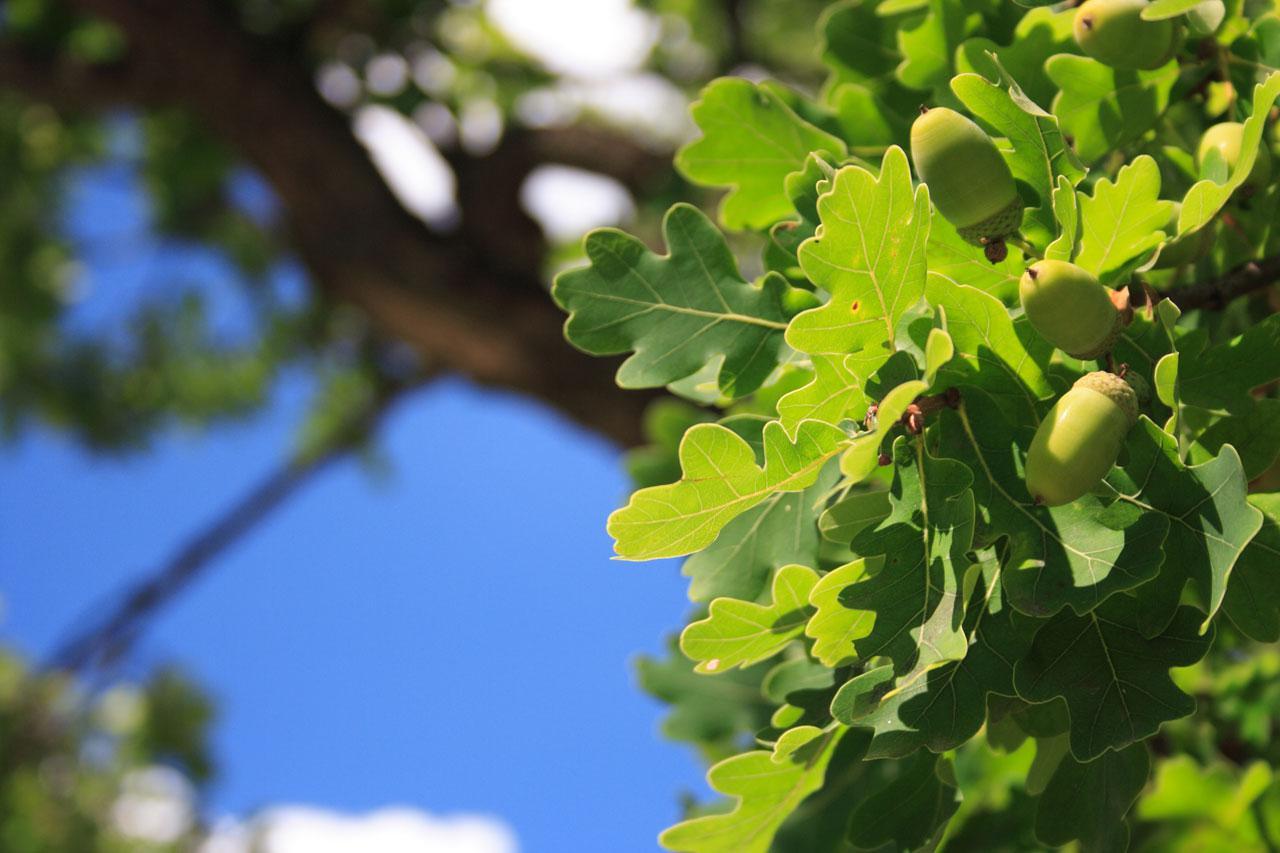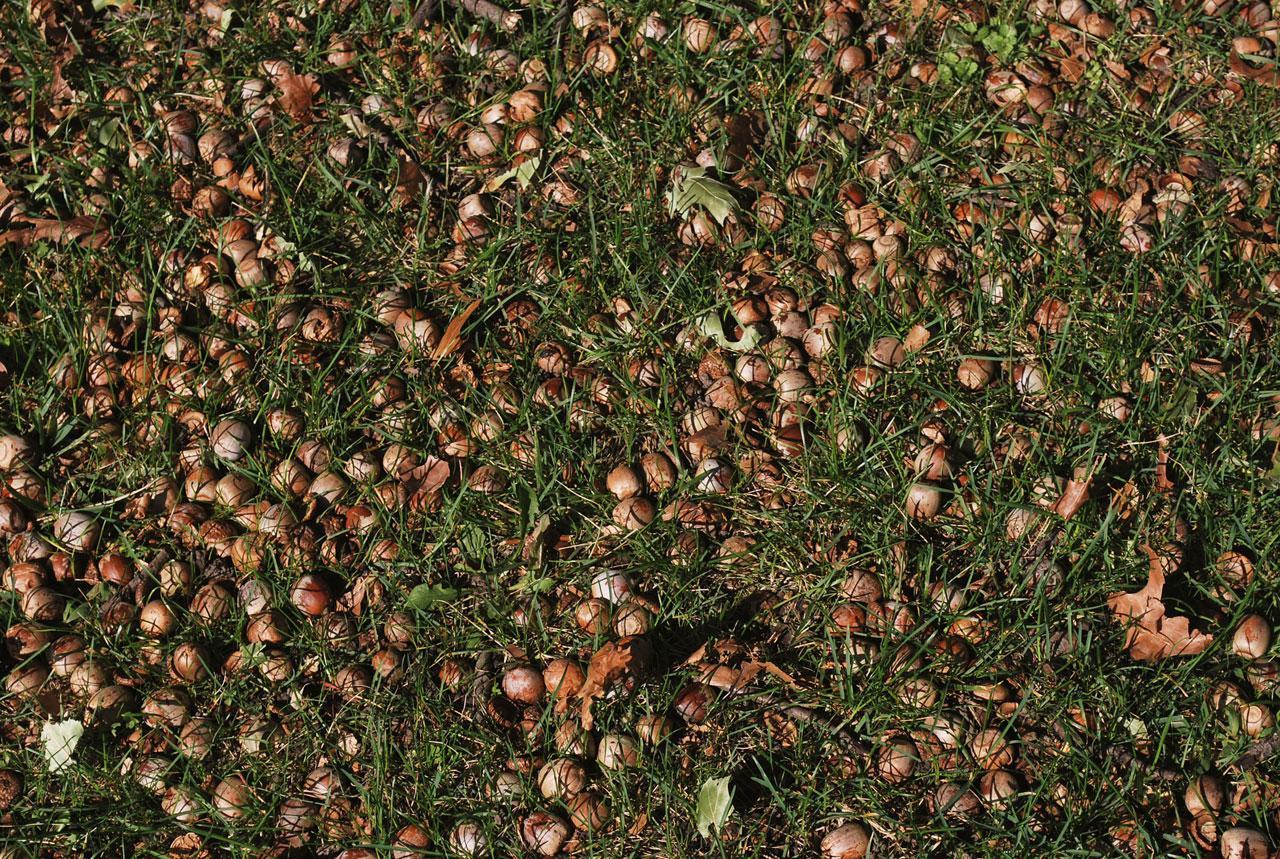The first image is the image on the left, the second image is the image on the right. Assess this claim about the two images: "One image shows exactly two brown acorns in back-to-back caps on green foliage.". Correct or not? Answer yes or no. No. 